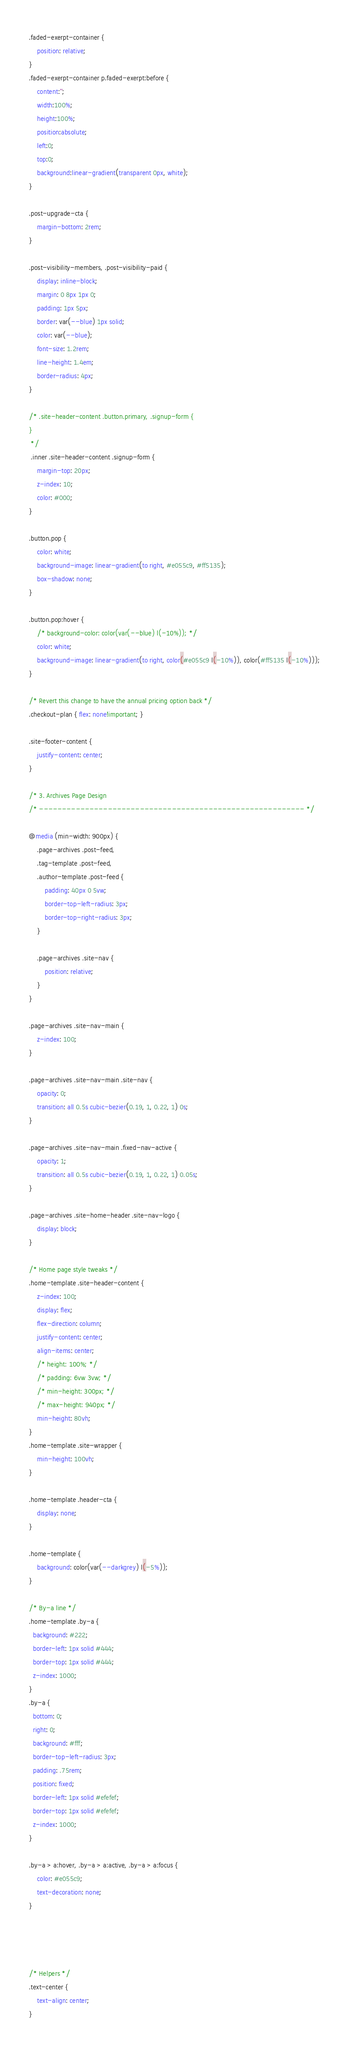Convert code to text. <code><loc_0><loc_0><loc_500><loc_500><_CSS_>.faded-exerpt-container {
    position: relative;
}
.faded-exerpt-container p.faded-exerpt:before {
    content:'';
    width:100%;
    height:100%;    
    position:absolute;
    left:0;
    top:0;
    background:linear-gradient(transparent 0px, white);
}

.post-upgrade-cta {
    margin-bottom: 2rem;
}

.post-visibility-members, .post-visibility-paid {
    display: inline-block;
    margin: 0 8px 1px 0;
    padding: 1px 5px;
    border: var(--blue) 1px solid;
    color: var(--blue);
    font-size: 1.2rem;
    line-height: 1.4em;
    border-radius: 4px;
}

/* .site-header-content .button.primary, .signup-form {
}
 */
 .inner .site-header-content .signup-form {
    margin-top: 20px;
    z-index: 10;
    color: #000;
}

.button.pop {
    color: white;
    background-image: linear-gradient(to right, #e055c9, #ff5135);
    box-shadow: none;
}

.button.pop:hover {
    /* background-color: color(var(--blue) l(-10%)); */
    color: white;
    background-image: linear-gradient(to right, color(#e055c9 l(-10%)), color(#ff5135 l(-10%)));
}

/* Revert this change to have the annual pricing option back */
.checkout-plan { flex: none!important; }

.site-footer-content {
    justify-content: center;
}

/* 3. Archives Page Design
/* ---------------------------------------------------------- */

@media (min-width: 900px) {
    .page-archives .post-feed,
    .tag-template .post-feed,
    .author-template .post-feed {
        padding: 40px 0 5vw;
        border-top-left-radius: 3px;
        border-top-right-radius: 3px;
    }

    .page-archives .site-nav {
        position: relative;
    }
}

.page-archives .site-nav-main {
    z-index: 100;
}

.page-archives .site-nav-main .site-nav {
    opacity: 0;
    transition: all 0.5s cubic-bezier(0.19, 1, 0.22, 1) 0s;
}

.page-archives .site-nav-main .fixed-nav-active {
    opacity: 1;
    transition: all 0.5s cubic-bezier(0.19, 1, 0.22, 1) 0.05s;
}

.page-archives .site-home-header .site-nav-logo {
    display: block;
}

/* Home page style tweaks */
.home-template .site-header-content {
    z-index: 100;
    display: flex;
    flex-direction: column;
    justify-content: center;
    align-items: center;
    /* height: 100%; */
    /* padding: 6vw 3vw; */
    /* min-height: 300px; */
    /* max-height: 940px; */
    min-height: 80vh;
}
.home-template .site-wrapper {
    min-height: 100vh;
}

.home-template .header-cta {
    display: none;
}

.home-template {
    background: color(var(--darkgrey) l(-5%));
}

/* By-a line */
.home-template .by-a {
  background: #222;
  border-left: 1px solid #444;
  border-top: 1px solid #444;
  z-index: 1000;
}
.by-a {
  bottom: 0;
  right: 0;
  background: #fff;
  border-top-left-radius: 3px;
  padding: .75rem;
  position: fixed;
  border-left: 1px solid #efefef;
  border-top: 1px solid #efefef;
  z-index: 1000;
}

.by-a > a:hover, .by-a > a:active, .by-a > a:focus {
    color: #e055c9;
    text-decoration: none;
}




/* Helpers */
.text-center {
    text-align: center;
}</code> 